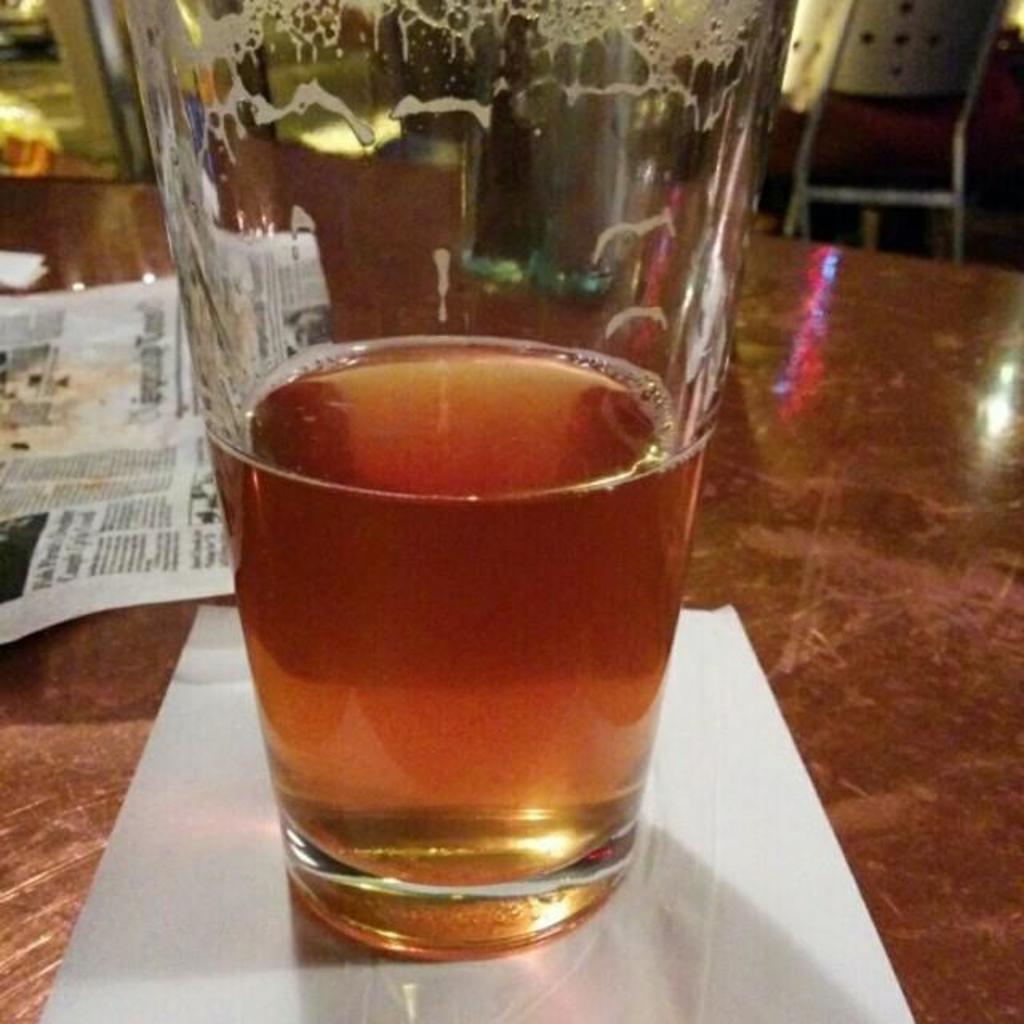How would you summarize this image in a sentence or two? In this image there is a glass on the table having few papers. The glass is filled with drink. Right top there is a chair. 